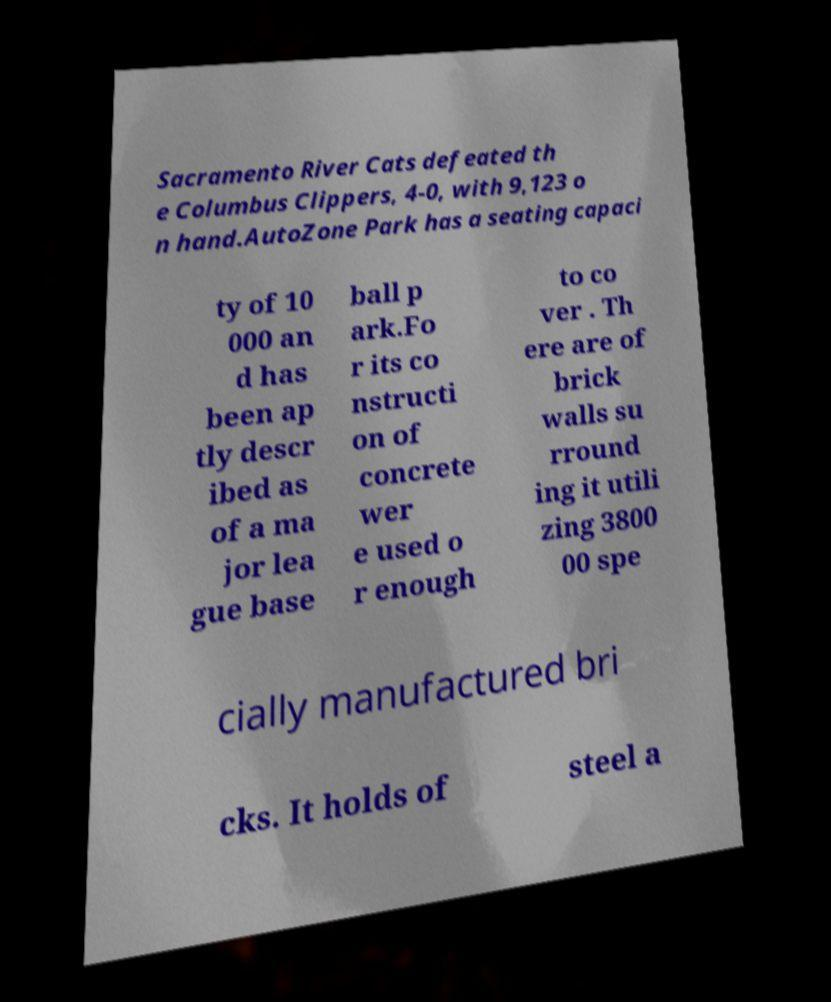Please identify and transcribe the text found in this image. Sacramento River Cats defeated th e Columbus Clippers, 4-0, with 9,123 o n hand.AutoZone Park has a seating capaci ty of 10 000 an d has been ap tly descr ibed as of a ma jor lea gue base ball p ark.Fo r its co nstructi on of concrete wer e used o r enough to co ver . Th ere are of brick walls su rround ing it utili zing 3800 00 spe cially manufactured bri cks. It holds of steel a 